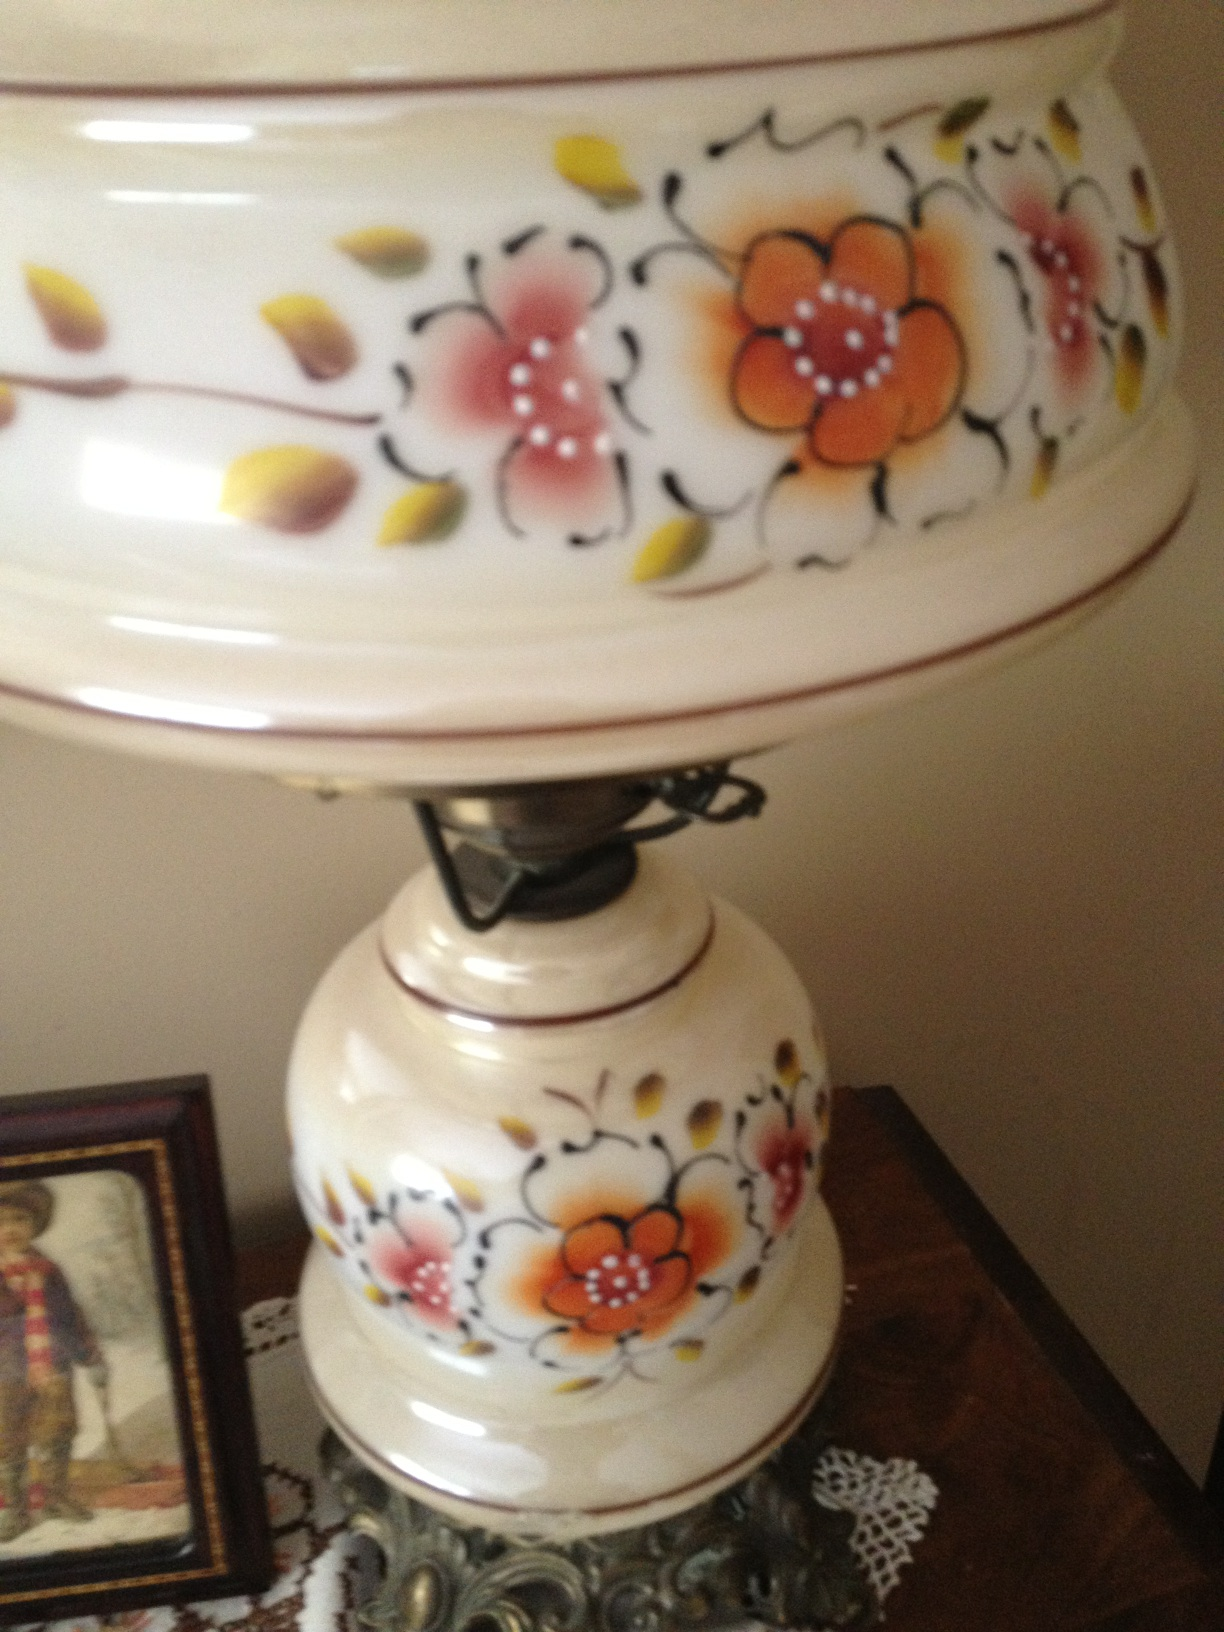How might this item be used in daily life? Although primarily ornamental, this tea urn can be used in daily life for serving tea during family gatherings or social events, offering both functionality and a touch of ornate decor to everyday settings. Is this type of ceramic item durable? Ceramic items like this are moderately durable. They are susceptible to cracking or breaking if mishandled, but with proper care, they can last for many years, even becoming cherished heirlooms. 